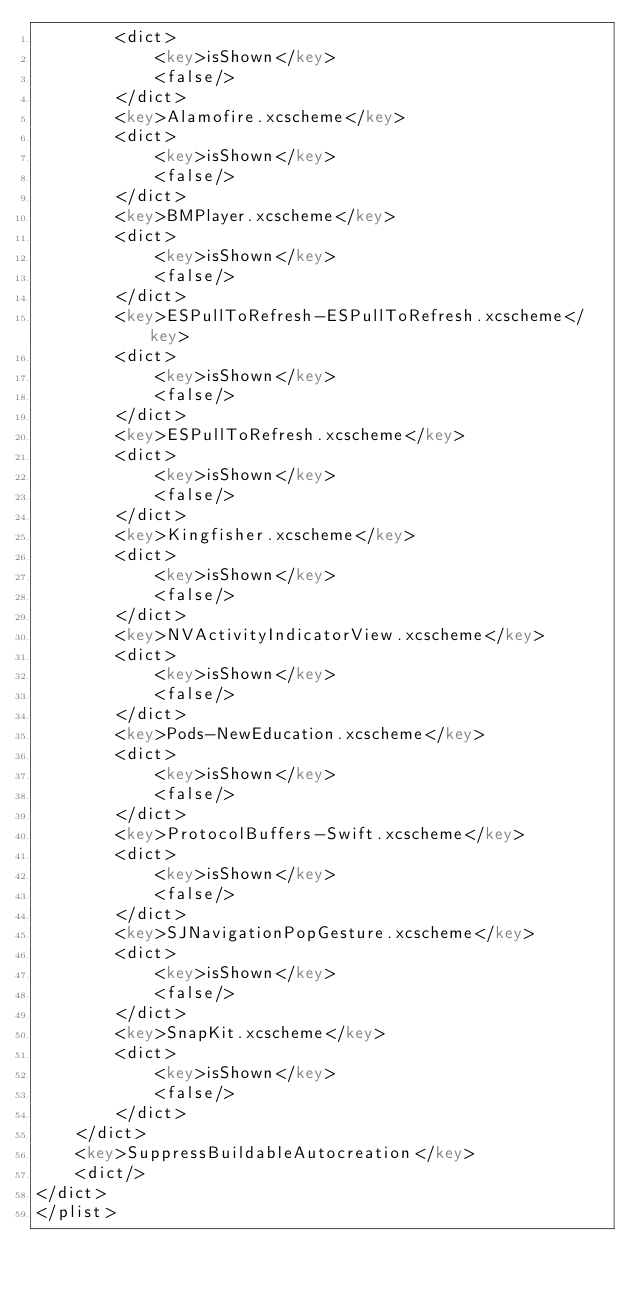<code> <loc_0><loc_0><loc_500><loc_500><_XML_>		<dict>
			<key>isShown</key>
			<false/>
		</dict>
		<key>Alamofire.xcscheme</key>
		<dict>
			<key>isShown</key>
			<false/>
		</dict>
		<key>BMPlayer.xcscheme</key>
		<dict>
			<key>isShown</key>
			<false/>
		</dict>
		<key>ESPullToRefresh-ESPullToRefresh.xcscheme</key>
		<dict>
			<key>isShown</key>
			<false/>
		</dict>
		<key>ESPullToRefresh.xcscheme</key>
		<dict>
			<key>isShown</key>
			<false/>
		</dict>
		<key>Kingfisher.xcscheme</key>
		<dict>
			<key>isShown</key>
			<false/>
		</dict>
		<key>NVActivityIndicatorView.xcscheme</key>
		<dict>
			<key>isShown</key>
			<false/>
		</dict>
		<key>Pods-NewEducation.xcscheme</key>
		<dict>
			<key>isShown</key>
			<false/>
		</dict>
		<key>ProtocolBuffers-Swift.xcscheme</key>
		<dict>
			<key>isShown</key>
			<false/>
		</dict>
		<key>SJNavigationPopGesture.xcscheme</key>
		<dict>
			<key>isShown</key>
			<false/>
		</dict>
		<key>SnapKit.xcscheme</key>
		<dict>
			<key>isShown</key>
			<false/>
		</dict>
	</dict>
	<key>SuppressBuildableAutocreation</key>
	<dict/>
</dict>
</plist>
</code> 